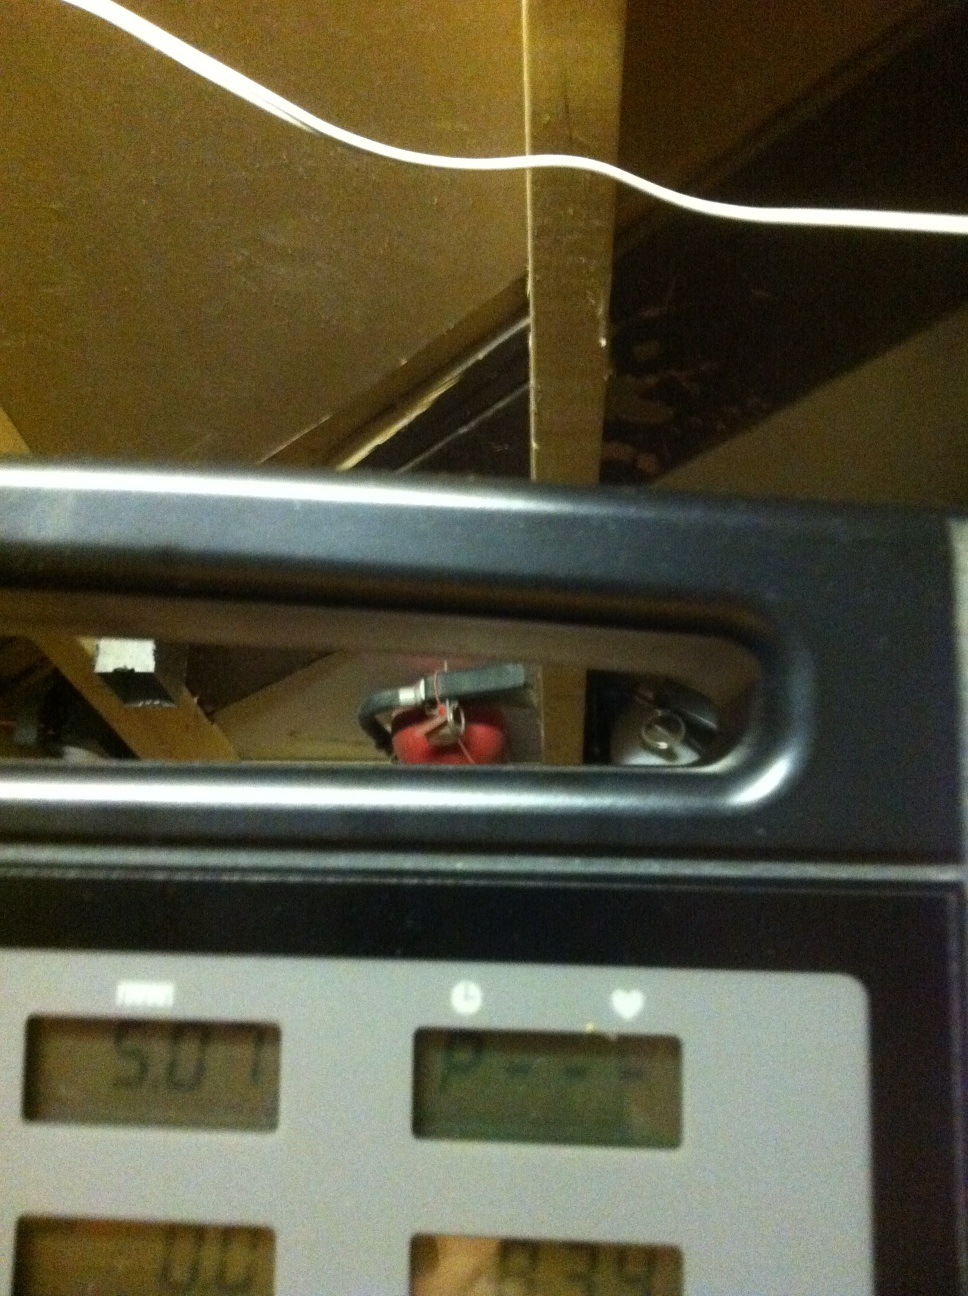This is the display of a treadmill could you tell me the distance please? The display indicates that the distance covered on the treadmill is 5.07 miles. 